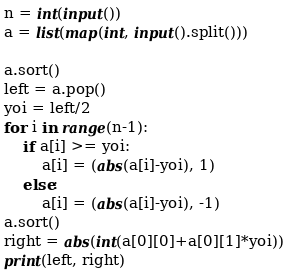<code> <loc_0><loc_0><loc_500><loc_500><_Python_>n = int(input())
a = list(map(int, input().split()))

a.sort()
left = a.pop()
yoi = left/2
for i in range(n-1):
    if a[i] >= yoi:
        a[i] = (abs(a[i]-yoi), 1)
    else:
        a[i] = (abs(a[i]-yoi), -1)
a.sort()
right = abs(int(a[0][0]+a[0][1]*yoi))
print(left, right)</code> 